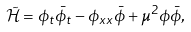<formula> <loc_0><loc_0><loc_500><loc_500>\mathcal { \tilde { H } } = \phi _ { t } \bar { \phi } _ { t } - \phi _ { x x } \bar { \phi } + \mu ^ { 2 } \phi \bar { \phi } ,</formula> 